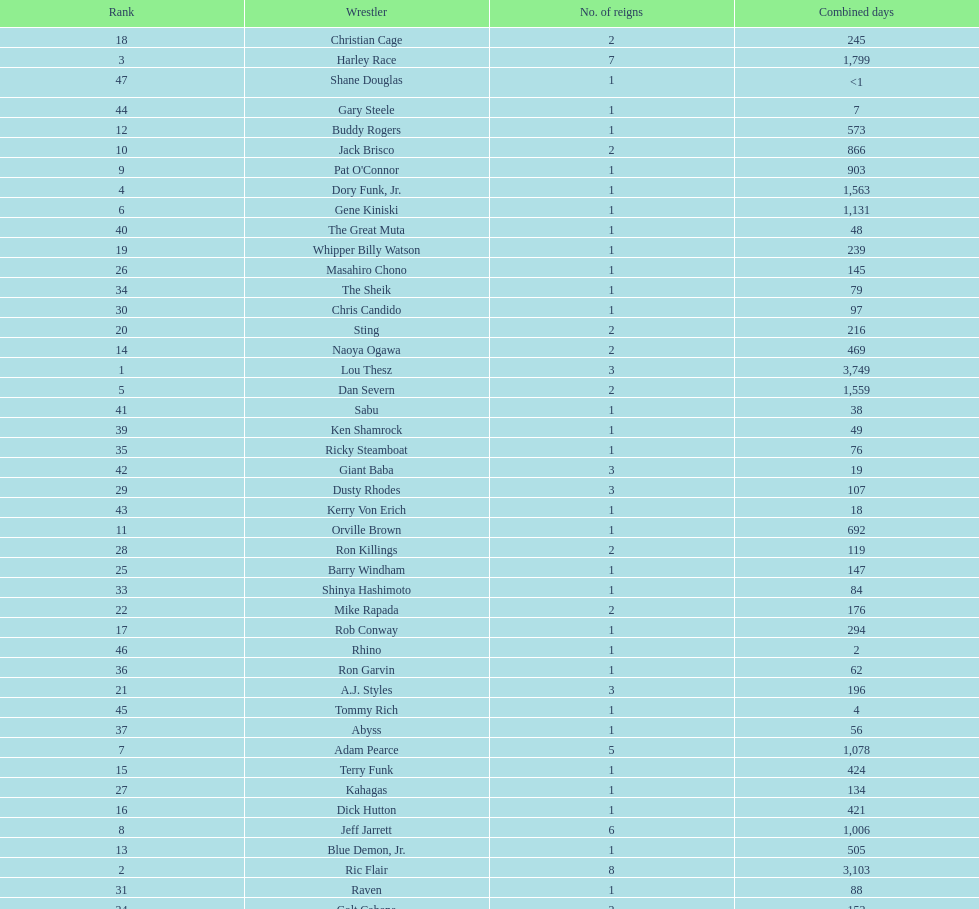How long did orville brown remain nwa world heavyweight champion? 692 days. 